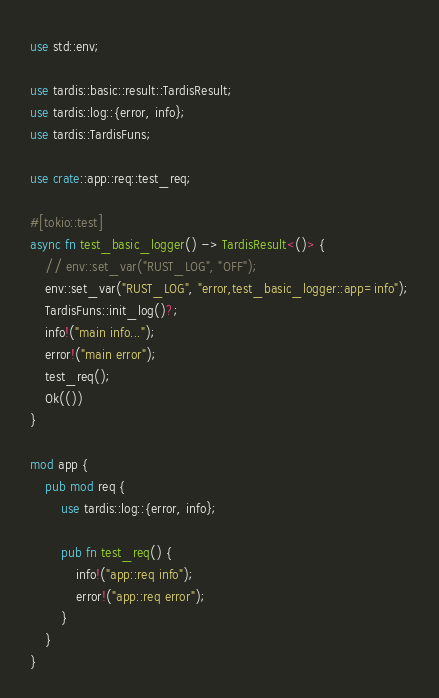Convert code to text. <code><loc_0><loc_0><loc_500><loc_500><_Rust_>use std::env;

use tardis::basic::result::TardisResult;
use tardis::log::{error, info};
use tardis::TardisFuns;

use crate::app::req::test_req;

#[tokio::test]
async fn test_basic_logger() -> TardisResult<()> {
    // env::set_var("RUST_LOG", "OFF");
    env::set_var("RUST_LOG", "error,test_basic_logger::app=info");
    TardisFuns::init_log()?;
    info!("main info...");
    error!("main error");
    test_req();
    Ok(())
}

mod app {
    pub mod req {
        use tardis::log::{error, info};

        pub fn test_req() {
            info!("app::req info");
            error!("app::req error");
        }
    }
}
</code> 